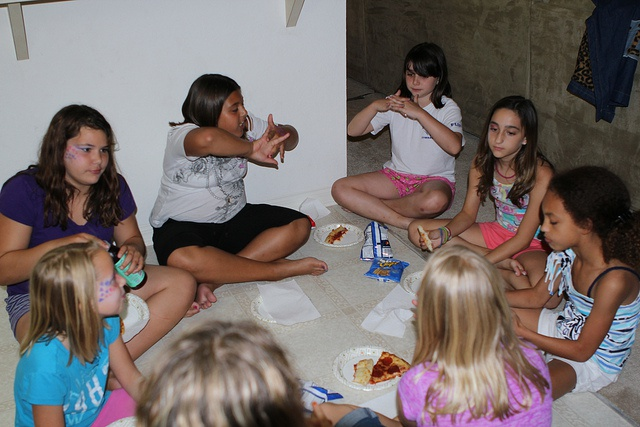Describe the objects in this image and their specific colors. I can see people in darkgray, black, maroon, and brown tones, people in darkgray, gray, and brown tones, people in darkgray, black, maroon, and brown tones, people in darkgray, teal, gray, and maroon tones, and people in darkgray, black, gray, navy, and maroon tones in this image. 